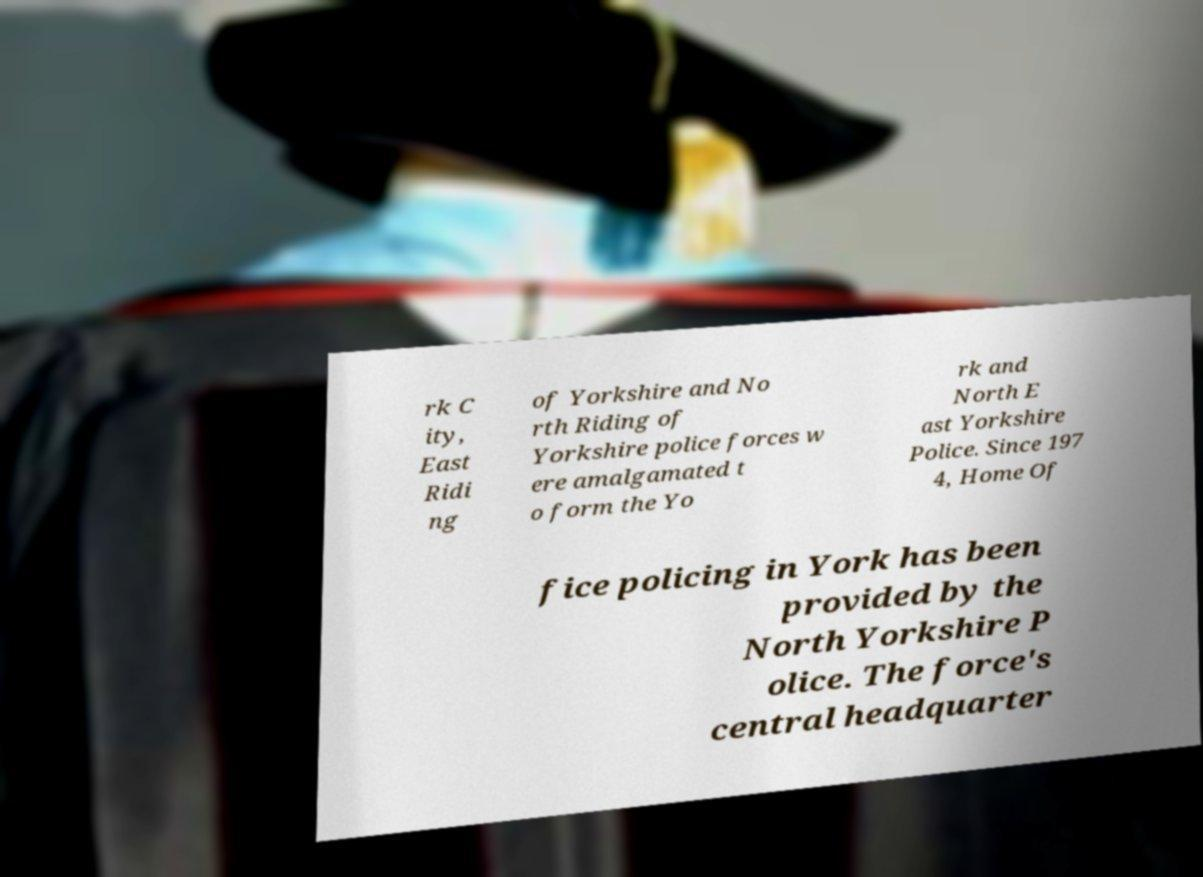What messages or text are displayed in this image? I need them in a readable, typed format. rk C ity, East Ridi ng of Yorkshire and No rth Riding of Yorkshire police forces w ere amalgamated t o form the Yo rk and North E ast Yorkshire Police. Since 197 4, Home Of fice policing in York has been provided by the North Yorkshire P olice. The force's central headquarter 